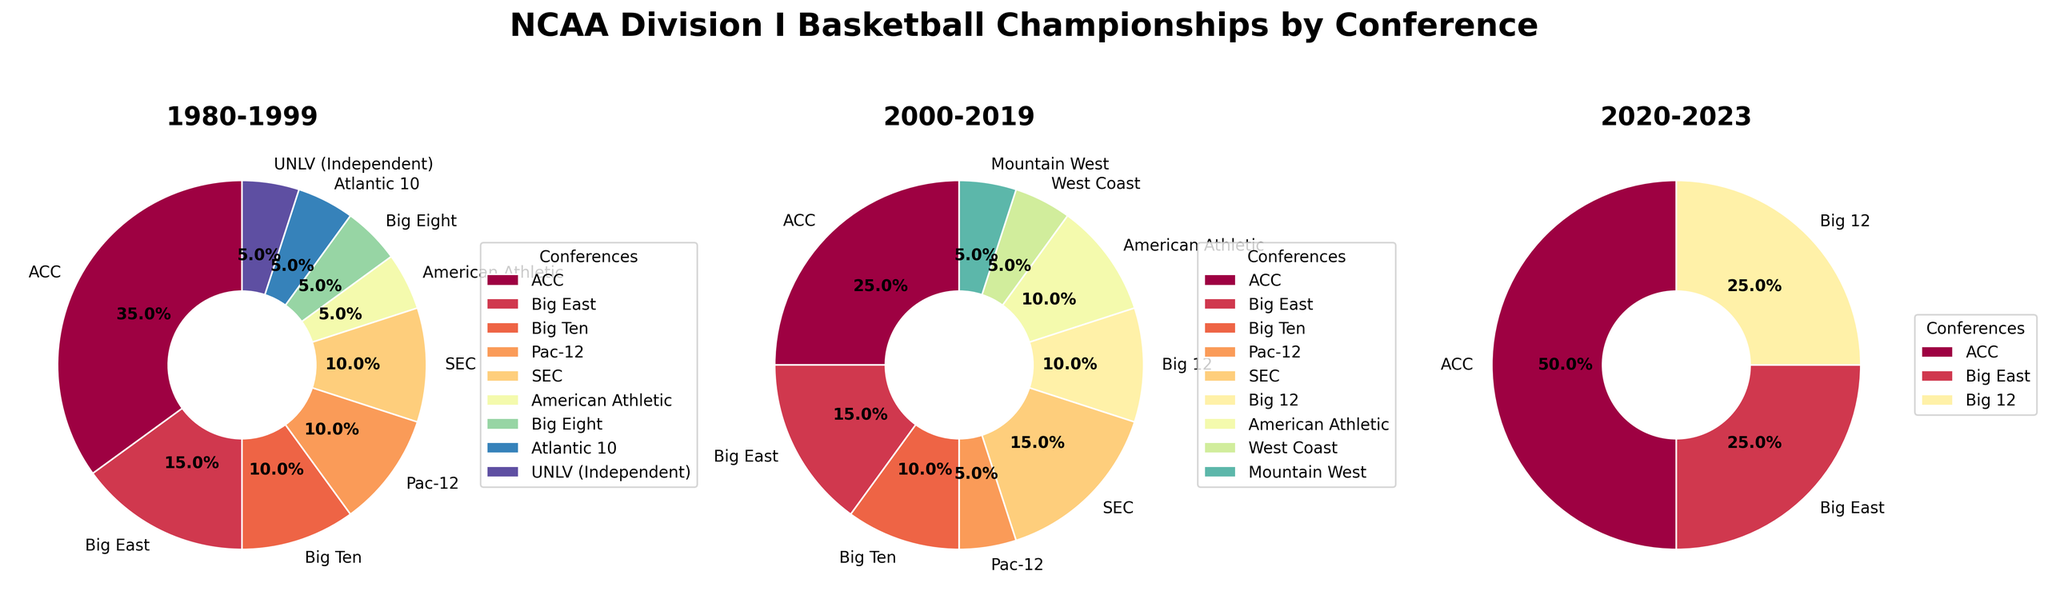Which conference won the most championships between 1980 and 1999? The 1980-1999 pie chart shows that the ACC has the largest slice labeled 7, indicating it won the most championships in that period.
Answer: ACC How many championships did the Big 12 win between 2000 and 2019? In the 2000-2019 pie chart, the Big 12's slice is labeled 2, indicating it won two championships in that period.
Answer: 2 Compare the number of championships won by the SEC and ACC from 2000 to 2019. Which conference won more? From the 2000-2019 pie chart, the ACC won 5 championships and the SEC won 3. The ACC won more championships.
Answer: ACC Which conference has never won a championship since 2020? The 2020-2023 pie chart does not show slices for the Big Ten, Pac-12, SEC, American Athletic, West Coast, Big Eight, Mountain West, Atlantic 10, and UNLV (Independent), indicating these conferences have not won any championships since 2020.
Answer: Big Ten, Pac-12, SEC, American Athletic, West Coast, Big Eight, Mountain West, Atlantic 10, UNLV (Independent) Compare the total number of championships won by ACC from 1980 to 2023 and those won by the Big East in the same period. Summing the values from all periods: 
ACC: 7 (1980-1999) + 5 (2000-2019) + 2 (2020-2023) = 14
Big East: 3 (1980-1999) + 3 (2000-2019) + 1 (2020-2023) = 7
The ACC won more championships than the Big East from 1980 to 2023.
Answer: ACC How many unique conferences have won championships from 2000 to 2019? The 2000-2019 pie chart has slices labeled for the ACC, Big East, Big Ten, Pac-12, SEC, Big 12, and American Athletic, indicating 7 unique conferences.
Answer: 7 What percentage of championships did the ACC win between 1980 and 1999? The 1980-1999 pie chart shows the ACC won 7 championships out of the total number among all conferences, represented by the largest slice labeled approximately 35%.
Answer: 35% Did the American Athletic conference win any championships between 1980 and 1999? The 1980-1999 pie chart does not show a slice for the American Athletic conference, indicating it did not win any championships in that period.
Answer: No Which conference had the smallest representation in the 1980-1999 period, and how many championships did it win? In the 1980-1999 pie chart, the smallest slices are labeled for Big Eight, Atlantic 10, and UNLV (Independent) each with one championship.
Answer: Big Eight, Atlantic 10, UNLV (Independent) - 1 each How many total championships were won between 2020 and 2023? Adding the numbers from the 2020-2023 pie chart, the ACC has 2, Big East has 1, and Big 12 has 1, totaling 4 championships.
Answer: 4 